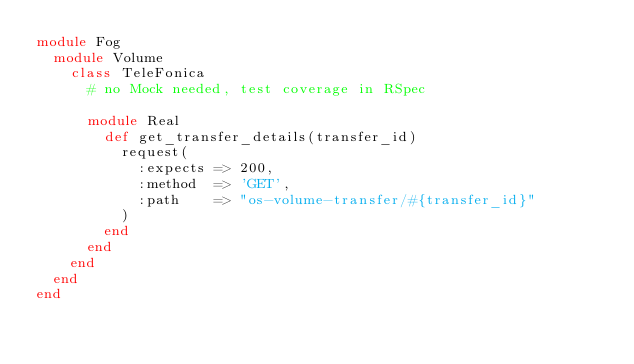Convert code to text. <code><loc_0><loc_0><loc_500><loc_500><_Ruby_>module Fog
  module Volume
    class TeleFonica
      # no Mock needed, test coverage in RSpec

      module Real
        def get_transfer_details(transfer_id)
          request(
            :expects => 200,
            :method  => 'GET',
            :path    => "os-volume-transfer/#{transfer_id}"
          )
        end
      end
    end
  end
end
</code> 